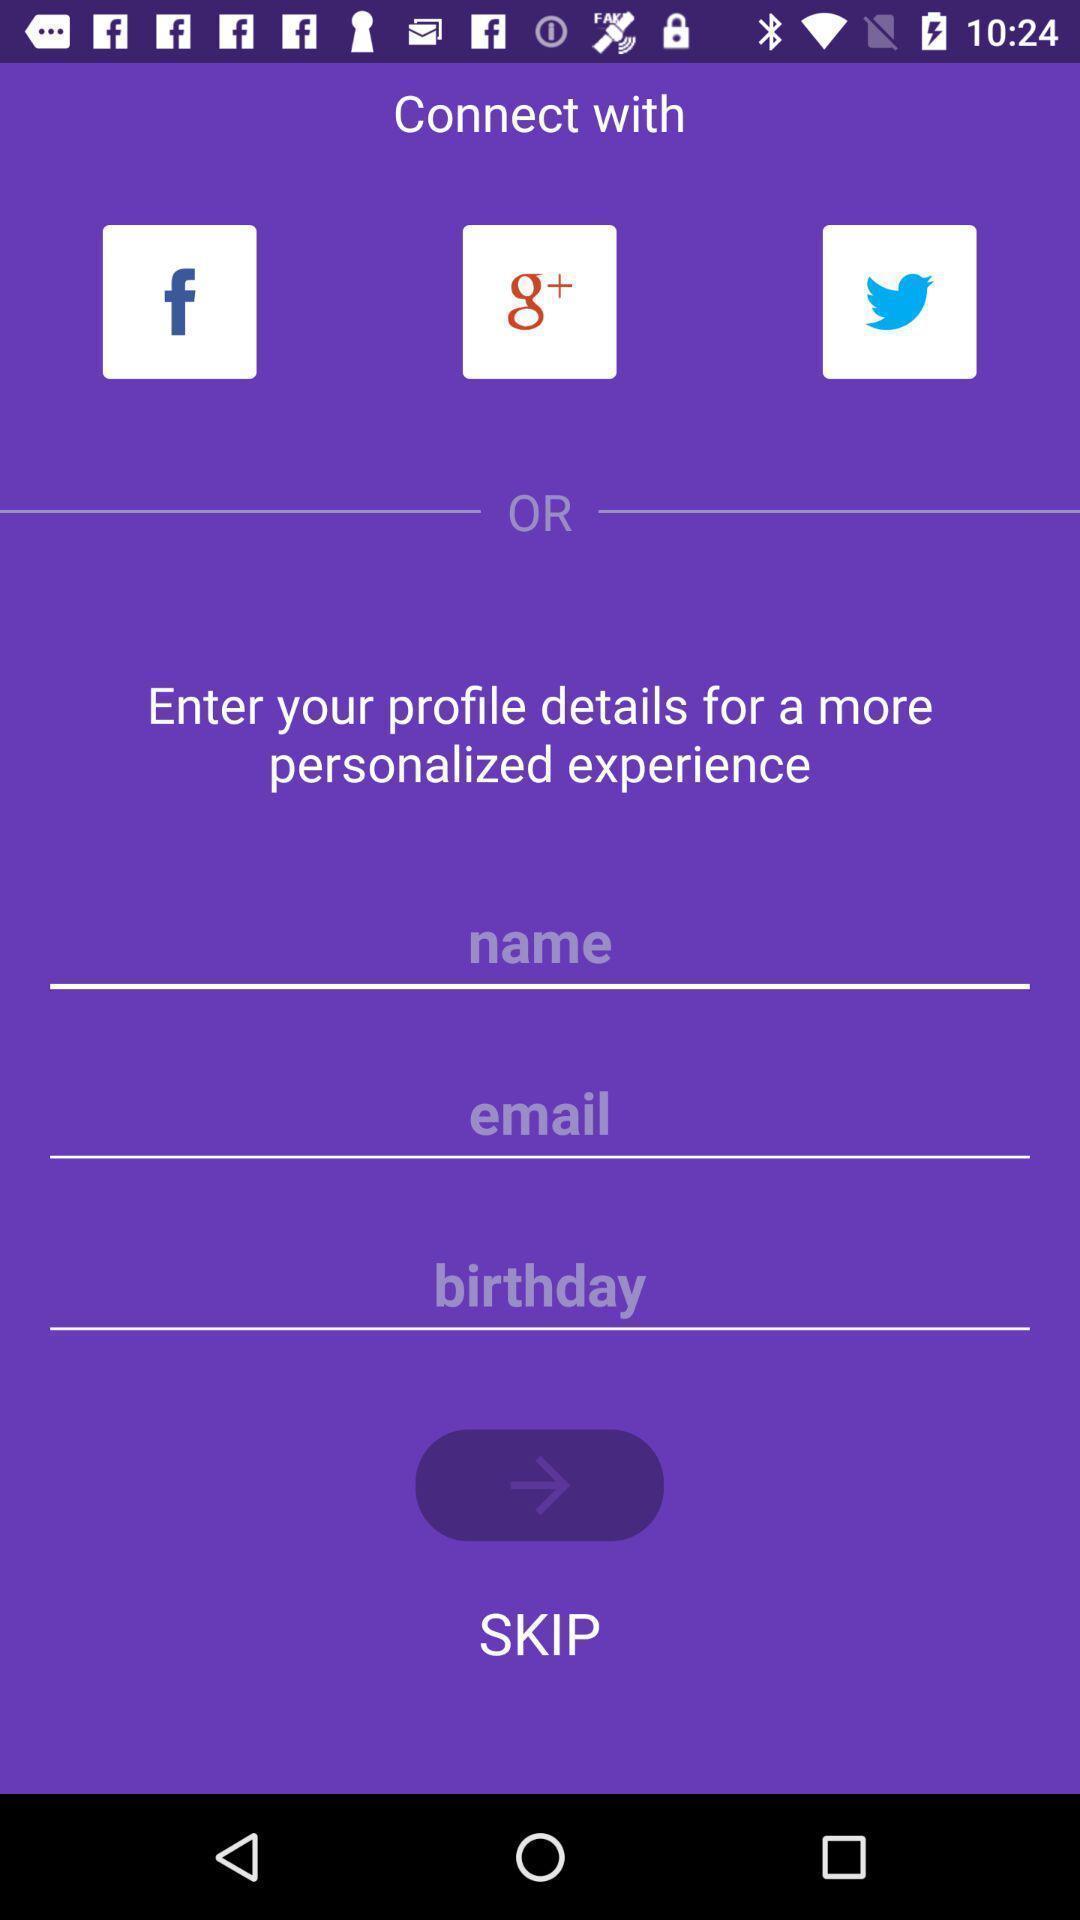Explain the elements present in this screenshot. Sign in page of a social app. 